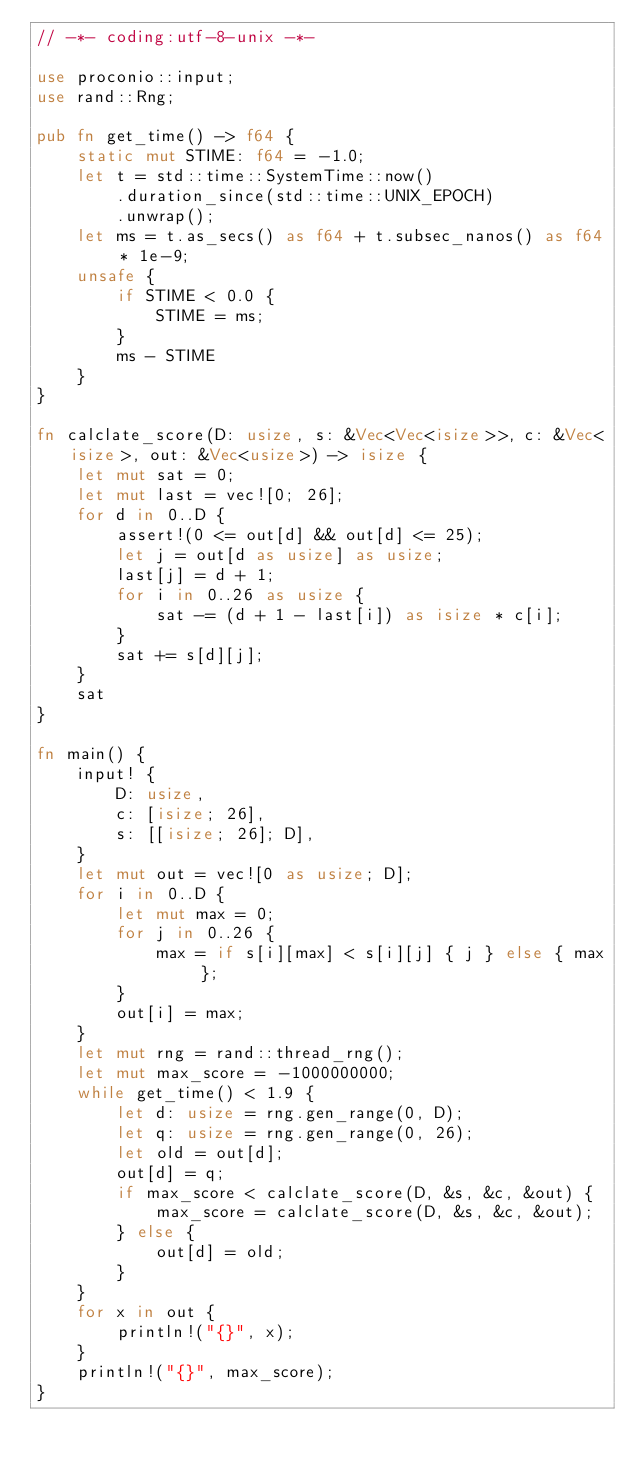Convert code to text. <code><loc_0><loc_0><loc_500><loc_500><_Rust_>// -*- coding:utf-8-unix -*-

use proconio::input;
use rand::Rng;

pub fn get_time() -> f64 {
    static mut STIME: f64 = -1.0;
    let t = std::time::SystemTime::now()
        .duration_since(std::time::UNIX_EPOCH)
        .unwrap();
    let ms = t.as_secs() as f64 + t.subsec_nanos() as f64 * 1e-9;
    unsafe {
        if STIME < 0.0 {
            STIME = ms;
        }
        ms - STIME
    }
}

fn calclate_score(D: usize, s: &Vec<Vec<isize>>, c: &Vec<isize>, out: &Vec<usize>) -> isize {
    let mut sat = 0;
    let mut last = vec![0; 26];
    for d in 0..D {
        assert!(0 <= out[d] && out[d] <= 25);
        let j = out[d as usize] as usize;
        last[j] = d + 1;
        for i in 0..26 as usize {
            sat -= (d + 1 - last[i]) as isize * c[i];
        }
        sat += s[d][j];
    }
    sat
}

fn main() {
    input! {
        D: usize,
        c: [isize; 26],
        s: [[isize; 26]; D],
    }
    let mut out = vec![0 as usize; D];
    for i in 0..D {
        let mut max = 0;
        for j in 0..26 {
            max = if s[i][max] < s[i][j] { j } else { max };
        }
        out[i] = max;
    }
    let mut rng = rand::thread_rng();
    let mut max_score = -1000000000;
    while get_time() < 1.9 {
        let d: usize = rng.gen_range(0, D);
        let q: usize = rng.gen_range(0, 26);
        let old = out[d];
        out[d] = q;
        if max_score < calclate_score(D, &s, &c, &out) {
            max_score = calclate_score(D, &s, &c, &out);
        } else {
            out[d] = old;
        }
    }
    for x in out {
        println!("{}", x);
    }
    println!("{}", max_score);
}
</code> 